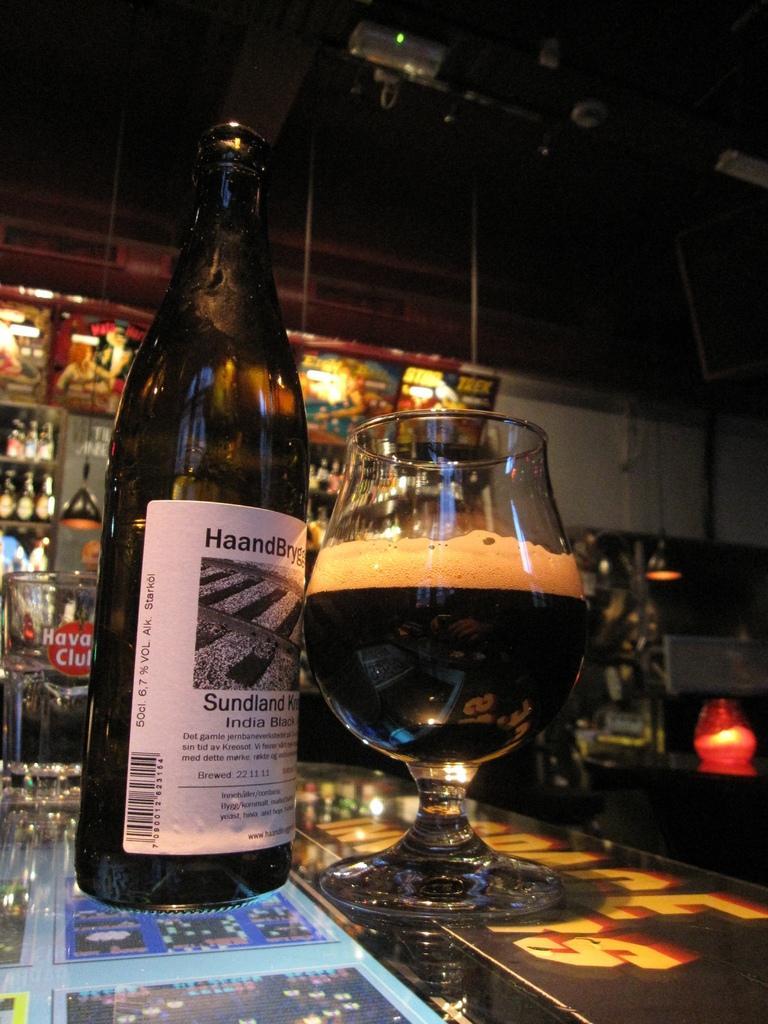Could you give a brief overview of what you see in this image? In the middle there is a table on that table there is a glass with drink inside it and bottle. In the background there are many bottles and light. 